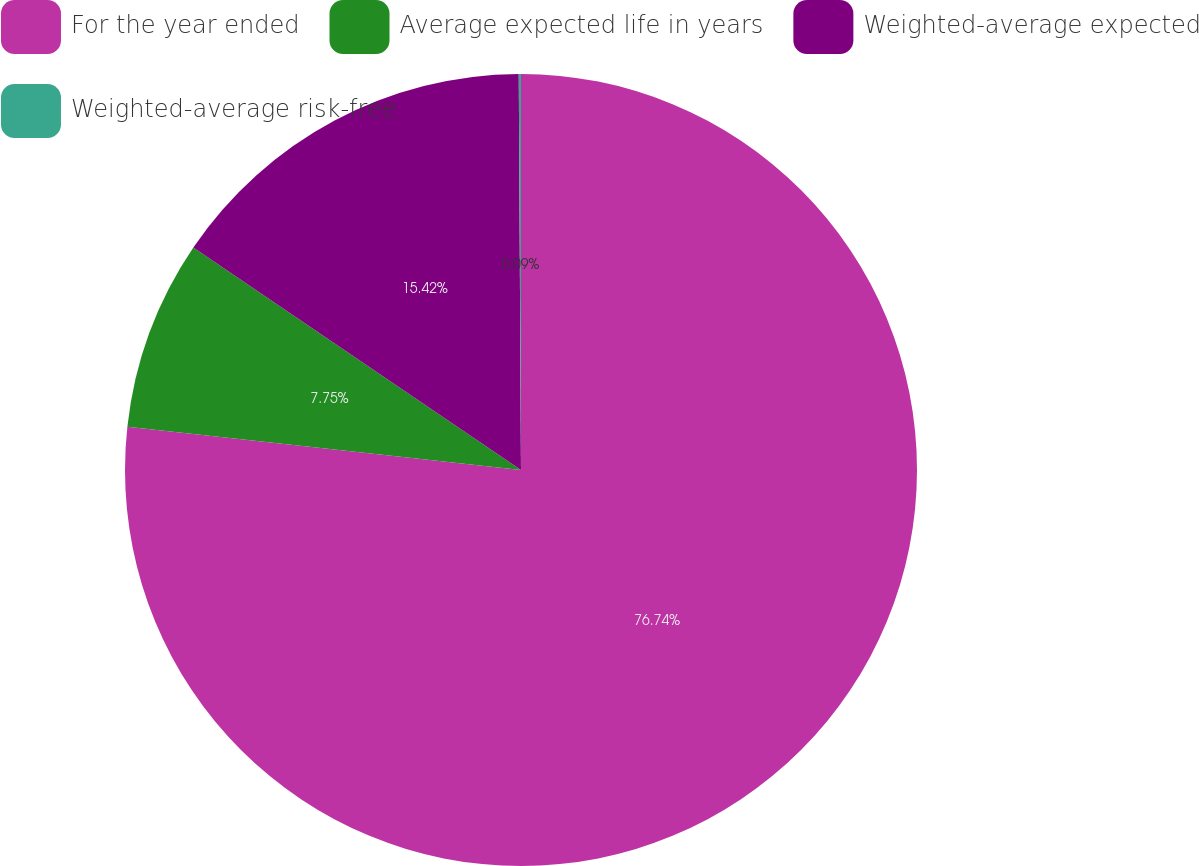Convert chart to OTSL. <chart><loc_0><loc_0><loc_500><loc_500><pie_chart><fcel>For the year ended<fcel>Average expected life in years<fcel>Weighted-average expected<fcel>Weighted-average risk-free<nl><fcel>76.74%<fcel>7.75%<fcel>15.42%<fcel>0.09%<nl></chart> 